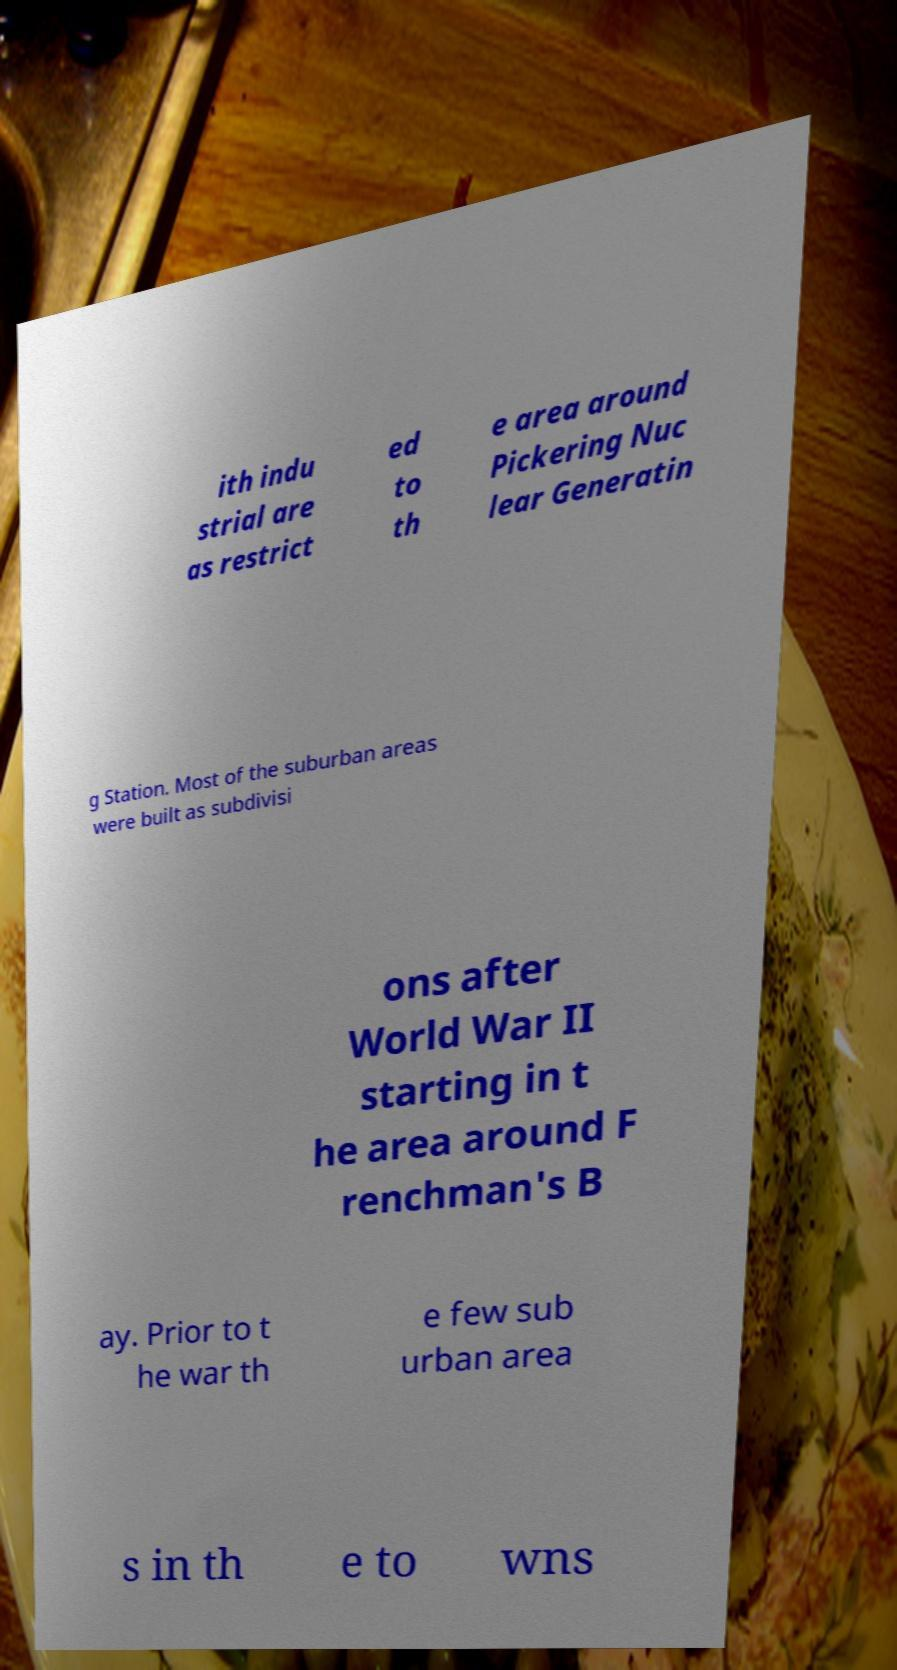Could you extract and type out the text from this image? ith indu strial are as restrict ed to th e area around Pickering Nuc lear Generatin g Station. Most of the suburban areas were built as subdivisi ons after World War II starting in t he area around F renchman's B ay. Prior to t he war th e few sub urban area s in th e to wns 